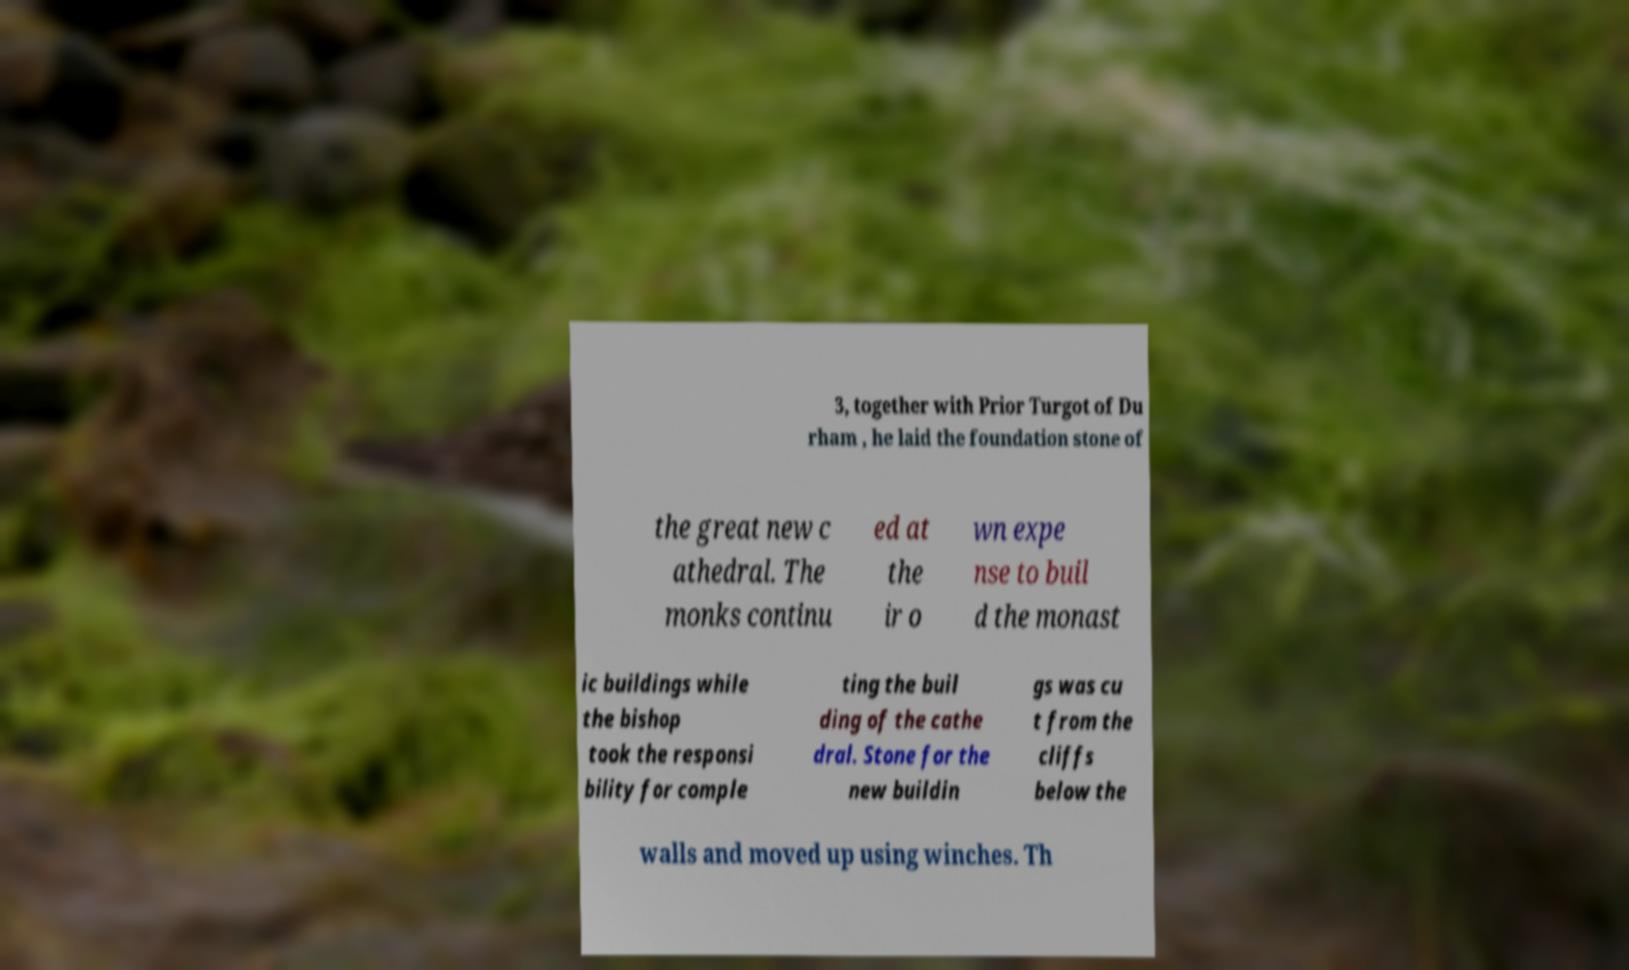Could you extract and type out the text from this image? 3, together with Prior Turgot of Du rham , he laid the foundation stone of the great new c athedral. The monks continu ed at the ir o wn expe nse to buil d the monast ic buildings while the bishop took the responsi bility for comple ting the buil ding of the cathe dral. Stone for the new buildin gs was cu t from the cliffs below the walls and moved up using winches. Th 